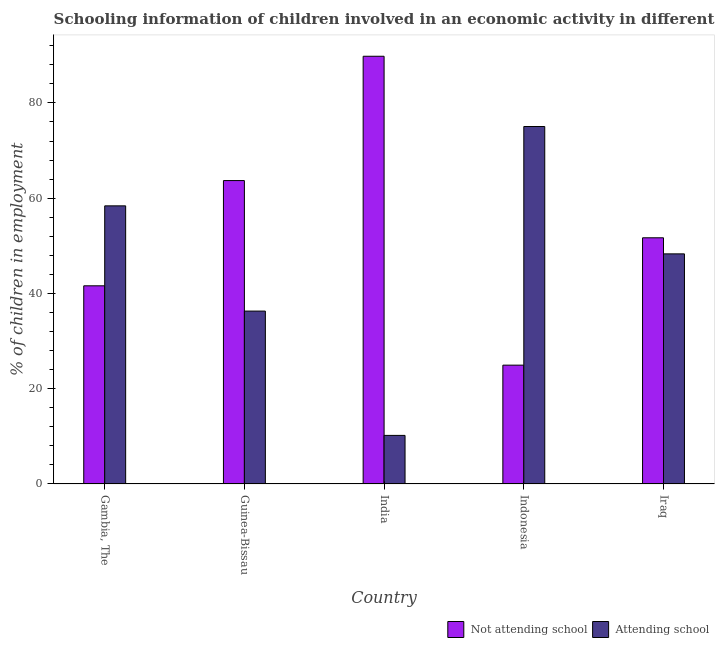How many different coloured bars are there?
Offer a terse response. 2. Are the number of bars on each tick of the X-axis equal?
Your response must be concise. Yes. What is the label of the 1st group of bars from the left?
Your answer should be very brief. Gambia, The. What is the percentage of employed children who are attending school in Indonesia?
Provide a short and direct response. 75.05. Across all countries, what is the maximum percentage of employed children who are attending school?
Your answer should be very brief. 75.05. Across all countries, what is the minimum percentage of employed children who are not attending school?
Keep it short and to the point. 24.95. In which country was the percentage of employed children who are not attending school maximum?
Offer a terse response. India. In which country was the percentage of employed children who are attending school minimum?
Your response must be concise. India. What is the total percentage of employed children who are not attending school in the graph?
Offer a terse response. 271.74. What is the difference between the percentage of employed children who are not attending school in Gambia, The and that in India?
Your response must be concise. -48.19. What is the difference between the percentage of employed children who are attending school in Gambia, The and the percentage of employed children who are not attending school in India?
Your response must be concise. -31.41. What is the average percentage of employed children who are attending school per country?
Provide a succinct answer. 45.65. What is the difference between the percentage of employed children who are attending school and percentage of employed children who are not attending school in Indonesia?
Make the answer very short. 50.1. In how many countries, is the percentage of employed children who are not attending school greater than 88 %?
Your response must be concise. 1. What is the ratio of the percentage of employed children who are not attending school in Gambia, The to that in Guinea-Bissau?
Provide a succinct answer. 0.65. Is the percentage of employed children who are not attending school in Gambia, The less than that in Iraq?
Keep it short and to the point. Yes. Is the difference between the percentage of employed children who are attending school in India and Indonesia greater than the difference between the percentage of employed children who are not attending school in India and Indonesia?
Give a very brief answer. No. What is the difference between the highest and the second highest percentage of employed children who are not attending school?
Your answer should be compact. 26.1. What is the difference between the highest and the lowest percentage of employed children who are not attending school?
Your response must be concise. 64.85. In how many countries, is the percentage of employed children who are not attending school greater than the average percentage of employed children who are not attending school taken over all countries?
Ensure brevity in your answer.  2. What does the 2nd bar from the left in India represents?
Provide a succinct answer. Attending school. What does the 2nd bar from the right in Gambia, The represents?
Provide a succinct answer. Not attending school. Are all the bars in the graph horizontal?
Give a very brief answer. No. How many countries are there in the graph?
Offer a very short reply. 5. What is the difference between two consecutive major ticks on the Y-axis?
Give a very brief answer. 20. Are the values on the major ticks of Y-axis written in scientific E-notation?
Your answer should be very brief. No. How many legend labels are there?
Your answer should be very brief. 2. How are the legend labels stacked?
Your response must be concise. Horizontal. What is the title of the graph?
Give a very brief answer. Schooling information of children involved in an economic activity in different countries. Does "GDP" appear as one of the legend labels in the graph?
Your answer should be compact. No. What is the label or title of the X-axis?
Provide a short and direct response. Country. What is the label or title of the Y-axis?
Offer a terse response. % of children in employment. What is the % of children in employment of Not attending school in Gambia, The?
Offer a very short reply. 41.61. What is the % of children in employment of Attending school in Gambia, The?
Provide a succinct answer. 58.39. What is the % of children in employment of Not attending school in Guinea-Bissau?
Your answer should be compact. 63.7. What is the % of children in employment in Attending school in Guinea-Bissau?
Provide a succinct answer. 36.3. What is the % of children in employment in Not attending school in India?
Keep it short and to the point. 89.8. What is the % of children in employment of Not attending school in Indonesia?
Keep it short and to the point. 24.95. What is the % of children in employment in Attending school in Indonesia?
Provide a succinct answer. 75.05. What is the % of children in employment of Not attending school in Iraq?
Give a very brief answer. 51.69. What is the % of children in employment of Attending school in Iraq?
Give a very brief answer. 48.31. Across all countries, what is the maximum % of children in employment of Not attending school?
Offer a terse response. 89.8. Across all countries, what is the maximum % of children in employment in Attending school?
Provide a short and direct response. 75.05. Across all countries, what is the minimum % of children in employment in Not attending school?
Your answer should be very brief. 24.95. What is the total % of children in employment in Not attending school in the graph?
Provide a short and direct response. 271.74. What is the total % of children in employment in Attending school in the graph?
Offer a terse response. 228.26. What is the difference between the % of children in employment of Not attending school in Gambia, The and that in Guinea-Bissau?
Offer a very short reply. -22.09. What is the difference between the % of children in employment of Attending school in Gambia, The and that in Guinea-Bissau?
Offer a terse response. 22.09. What is the difference between the % of children in employment in Not attending school in Gambia, The and that in India?
Provide a succinct answer. -48.19. What is the difference between the % of children in employment in Attending school in Gambia, The and that in India?
Offer a terse response. 48.19. What is the difference between the % of children in employment of Not attending school in Gambia, The and that in Indonesia?
Your answer should be compact. 16.66. What is the difference between the % of children in employment in Attending school in Gambia, The and that in Indonesia?
Provide a succinct answer. -16.66. What is the difference between the % of children in employment of Not attending school in Gambia, The and that in Iraq?
Offer a very short reply. -10.08. What is the difference between the % of children in employment in Attending school in Gambia, The and that in Iraq?
Your answer should be compact. 10.08. What is the difference between the % of children in employment of Not attending school in Guinea-Bissau and that in India?
Make the answer very short. -26.1. What is the difference between the % of children in employment of Attending school in Guinea-Bissau and that in India?
Ensure brevity in your answer.  26.1. What is the difference between the % of children in employment of Not attending school in Guinea-Bissau and that in Indonesia?
Keep it short and to the point. 38.75. What is the difference between the % of children in employment in Attending school in Guinea-Bissau and that in Indonesia?
Ensure brevity in your answer.  -38.75. What is the difference between the % of children in employment of Not attending school in Guinea-Bissau and that in Iraq?
Provide a succinct answer. 12.01. What is the difference between the % of children in employment of Attending school in Guinea-Bissau and that in Iraq?
Your response must be concise. -12.01. What is the difference between the % of children in employment of Not attending school in India and that in Indonesia?
Give a very brief answer. 64.85. What is the difference between the % of children in employment in Attending school in India and that in Indonesia?
Ensure brevity in your answer.  -64.85. What is the difference between the % of children in employment in Not attending school in India and that in Iraq?
Offer a terse response. 38.11. What is the difference between the % of children in employment in Attending school in India and that in Iraq?
Keep it short and to the point. -38.11. What is the difference between the % of children in employment of Not attending school in Indonesia and that in Iraq?
Make the answer very short. -26.74. What is the difference between the % of children in employment of Attending school in Indonesia and that in Iraq?
Make the answer very short. 26.74. What is the difference between the % of children in employment in Not attending school in Gambia, The and the % of children in employment in Attending school in Guinea-Bissau?
Your response must be concise. 5.31. What is the difference between the % of children in employment in Not attending school in Gambia, The and the % of children in employment in Attending school in India?
Keep it short and to the point. 31.41. What is the difference between the % of children in employment in Not attending school in Gambia, The and the % of children in employment in Attending school in Indonesia?
Ensure brevity in your answer.  -33.45. What is the difference between the % of children in employment in Not attending school in Gambia, The and the % of children in employment in Attending school in Iraq?
Provide a succinct answer. -6.71. What is the difference between the % of children in employment of Not attending school in Guinea-Bissau and the % of children in employment of Attending school in India?
Give a very brief answer. 53.5. What is the difference between the % of children in employment of Not attending school in Guinea-Bissau and the % of children in employment of Attending school in Indonesia?
Provide a succinct answer. -11.35. What is the difference between the % of children in employment of Not attending school in Guinea-Bissau and the % of children in employment of Attending school in Iraq?
Offer a terse response. 15.39. What is the difference between the % of children in employment of Not attending school in India and the % of children in employment of Attending school in Indonesia?
Provide a succinct answer. 14.75. What is the difference between the % of children in employment in Not attending school in India and the % of children in employment in Attending school in Iraq?
Make the answer very short. 41.49. What is the difference between the % of children in employment of Not attending school in Indonesia and the % of children in employment of Attending school in Iraq?
Ensure brevity in your answer.  -23.36. What is the average % of children in employment of Not attending school per country?
Give a very brief answer. 54.35. What is the average % of children in employment of Attending school per country?
Give a very brief answer. 45.65. What is the difference between the % of children in employment of Not attending school and % of children in employment of Attending school in Gambia, The?
Give a very brief answer. -16.79. What is the difference between the % of children in employment in Not attending school and % of children in employment in Attending school in Guinea-Bissau?
Provide a succinct answer. 27.4. What is the difference between the % of children in employment of Not attending school and % of children in employment of Attending school in India?
Provide a short and direct response. 79.6. What is the difference between the % of children in employment of Not attending school and % of children in employment of Attending school in Indonesia?
Offer a terse response. -50.1. What is the difference between the % of children in employment of Not attending school and % of children in employment of Attending school in Iraq?
Your answer should be very brief. 3.37. What is the ratio of the % of children in employment of Not attending school in Gambia, The to that in Guinea-Bissau?
Ensure brevity in your answer.  0.65. What is the ratio of the % of children in employment of Attending school in Gambia, The to that in Guinea-Bissau?
Your response must be concise. 1.61. What is the ratio of the % of children in employment of Not attending school in Gambia, The to that in India?
Your response must be concise. 0.46. What is the ratio of the % of children in employment in Attending school in Gambia, The to that in India?
Offer a very short reply. 5.72. What is the ratio of the % of children in employment of Not attending school in Gambia, The to that in Indonesia?
Ensure brevity in your answer.  1.67. What is the ratio of the % of children in employment of Attending school in Gambia, The to that in Indonesia?
Provide a short and direct response. 0.78. What is the ratio of the % of children in employment of Not attending school in Gambia, The to that in Iraq?
Make the answer very short. 0.8. What is the ratio of the % of children in employment in Attending school in Gambia, The to that in Iraq?
Offer a very short reply. 1.21. What is the ratio of the % of children in employment of Not attending school in Guinea-Bissau to that in India?
Your answer should be compact. 0.71. What is the ratio of the % of children in employment in Attending school in Guinea-Bissau to that in India?
Offer a very short reply. 3.56. What is the ratio of the % of children in employment of Not attending school in Guinea-Bissau to that in Indonesia?
Provide a short and direct response. 2.55. What is the ratio of the % of children in employment of Attending school in Guinea-Bissau to that in Indonesia?
Your answer should be compact. 0.48. What is the ratio of the % of children in employment of Not attending school in Guinea-Bissau to that in Iraq?
Offer a terse response. 1.23. What is the ratio of the % of children in employment in Attending school in Guinea-Bissau to that in Iraq?
Your answer should be compact. 0.75. What is the ratio of the % of children in employment of Not attending school in India to that in Indonesia?
Make the answer very short. 3.6. What is the ratio of the % of children in employment of Attending school in India to that in Indonesia?
Your answer should be very brief. 0.14. What is the ratio of the % of children in employment in Not attending school in India to that in Iraq?
Provide a succinct answer. 1.74. What is the ratio of the % of children in employment of Attending school in India to that in Iraq?
Provide a succinct answer. 0.21. What is the ratio of the % of children in employment of Not attending school in Indonesia to that in Iraq?
Your answer should be compact. 0.48. What is the ratio of the % of children in employment of Attending school in Indonesia to that in Iraq?
Keep it short and to the point. 1.55. What is the difference between the highest and the second highest % of children in employment of Not attending school?
Ensure brevity in your answer.  26.1. What is the difference between the highest and the second highest % of children in employment of Attending school?
Offer a very short reply. 16.66. What is the difference between the highest and the lowest % of children in employment in Not attending school?
Provide a short and direct response. 64.85. What is the difference between the highest and the lowest % of children in employment in Attending school?
Your answer should be very brief. 64.85. 